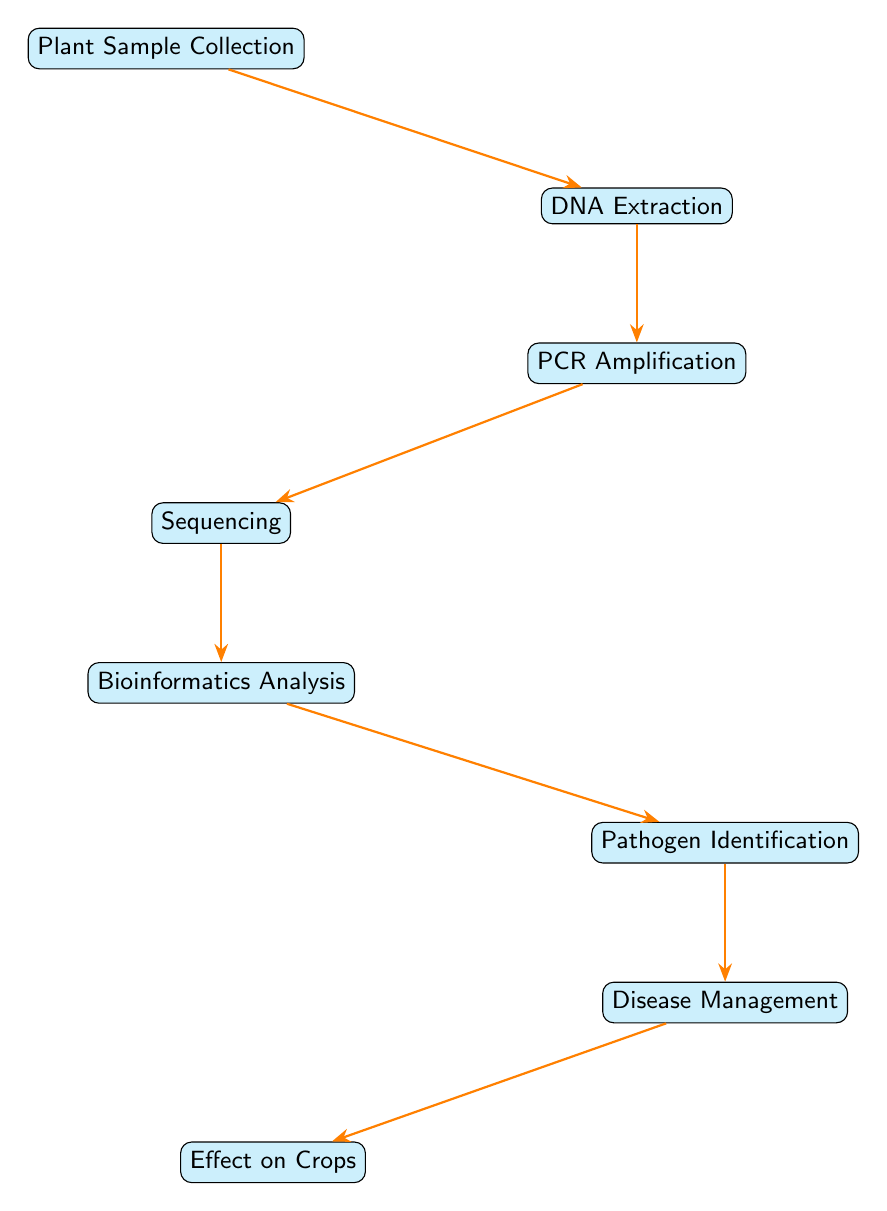What's the first step in the process? The first step is "Plant Sample Collection." This is indicated as the top node in the diagram, from which all other steps originate.
Answer: Plant Sample Collection How many total nodes are there in the diagram? By counting the listed nodes in the diagram, there are a total of 8 nodes: Plant Sample Collection, DNA Extraction, PCR Amplification, Sequencing, Bioinformatics Analysis, Pathogen Identification, Disease Management, and Effect on Crops.
Answer: 8 What connects DNA Extraction and PCR Amplification? The connection is represented by an arrow labeled "extract DNA," indicating the process that transforms the result of DNA Extraction into PCR Amplification.
Answer: extract DNA Which step follows Bioinformatics Analysis? The step that follows Bioinformatics Analysis is "Pathogen Identification," as indicated by the downward arrow connecting these two nodes in the flow of the diagram.
Answer: Pathogen Identification What is the last step in the diagram? The last step in the diagram is "Effect on Crops," which is located at the bottom and receives its input from "Disease Management."
Answer: Effect on Crops What does the process of PCR Amplification do? The process of PCR Amplification is described as "amplify DNA," which implies that it increases the quantity of DNA obtained from the extraction step.
Answer: amplify DNA How does the diagram illustrate the relationship between Disease Management and Effect on Crops? The diagram shows that "Disease Management" leads to "Effect on Crops" through a direct connection indicated by an arrow, emphasizing that managing diseases impacts crop outcomes.
Answer: manage disease What is the analytical step taken before Pathogen Identification? The analytical step taken before Pathogen Identification is "Bioinformatics Analysis," as it processes the sequenced DNA data needed for identifying pathogens.
Answer: Bioinformatics Analysis 